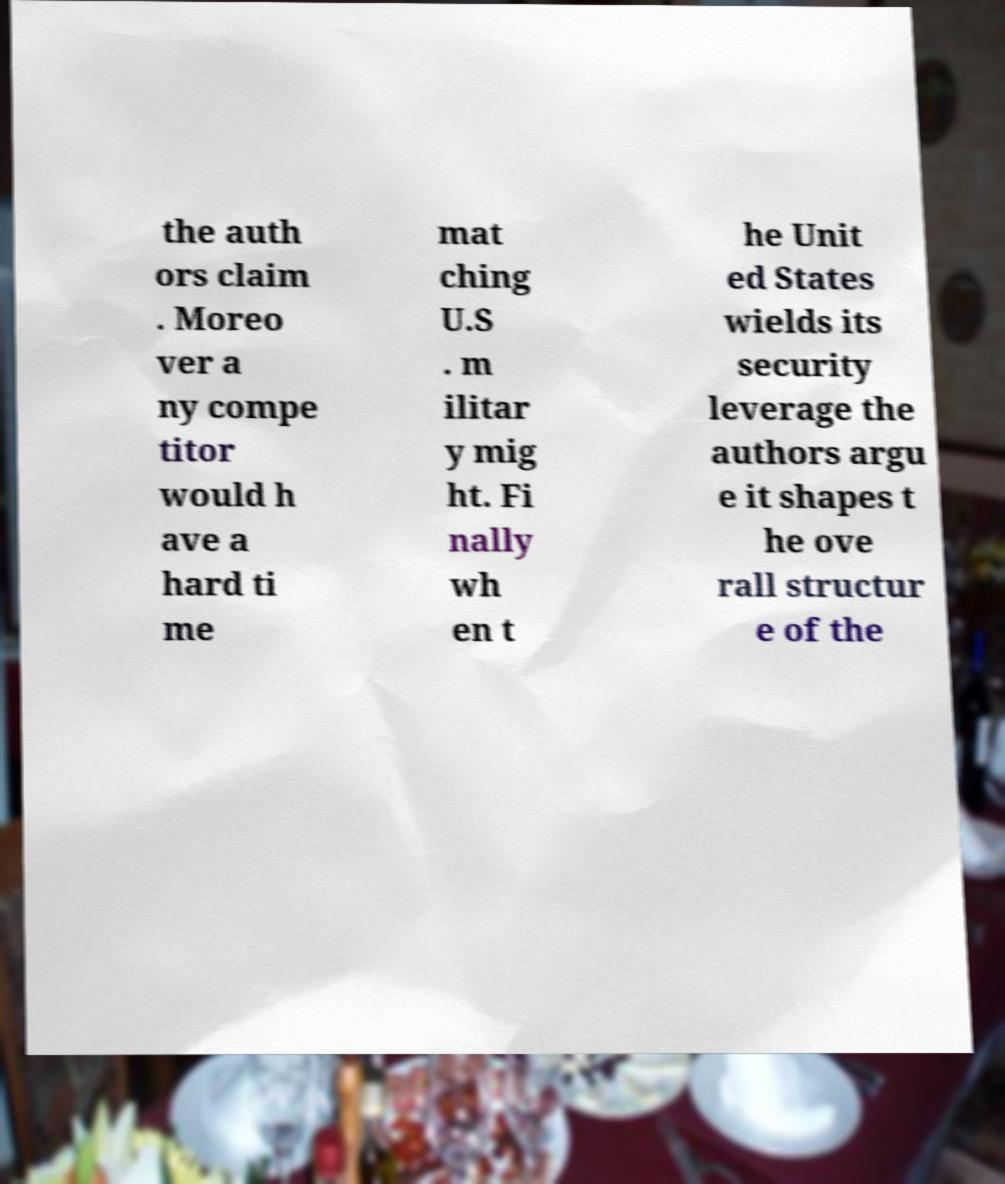For documentation purposes, I need the text within this image transcribed. Could you provide that? the auth ors claim . Moreo ver a ny compe titor would h ave a hard ti me mat ching U.S . m ilitar y mig ht. Fi nally wh en t he Unit ed States wields its security leverage the authors argu e it shapes t he ove rall structur e of the 